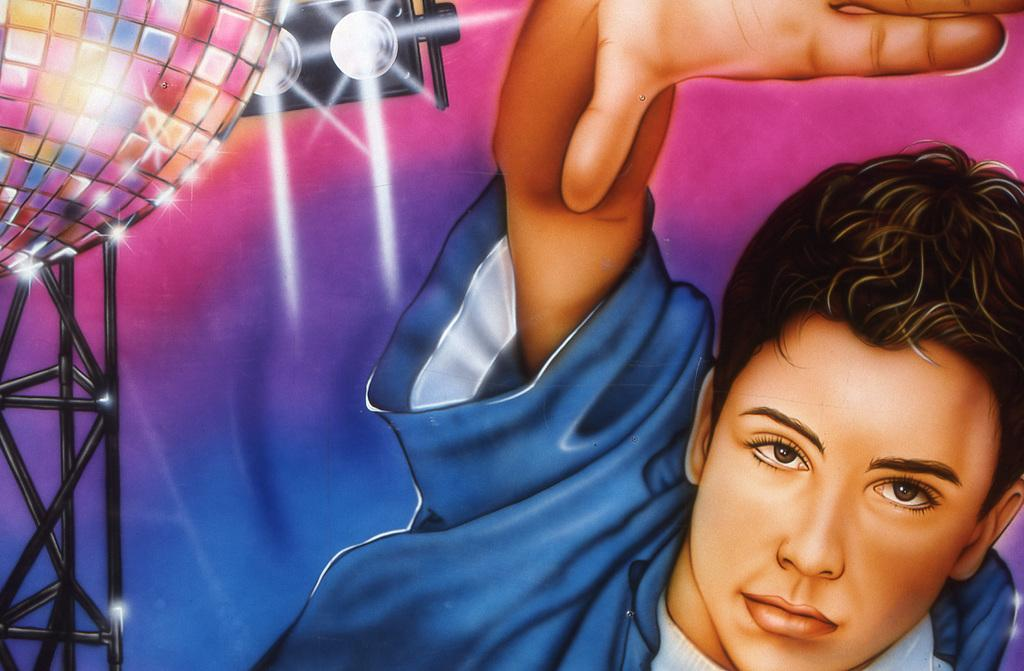What type of artwork is depicted in the image? The image is a painting. Who or what is the main subject of the painting? There is a man in the painting. What can be seen in the background of the painting? There are lights in the background of the painting. What flavor of cake is being served in the painting? There is no cake present in the painting; it features a man and lights in the background. How many screws can be seen holding the man's hat in place in the painting? There are no screws visible in the painting, as it is a painting of a man and lights in the background, not a mechanical object. 